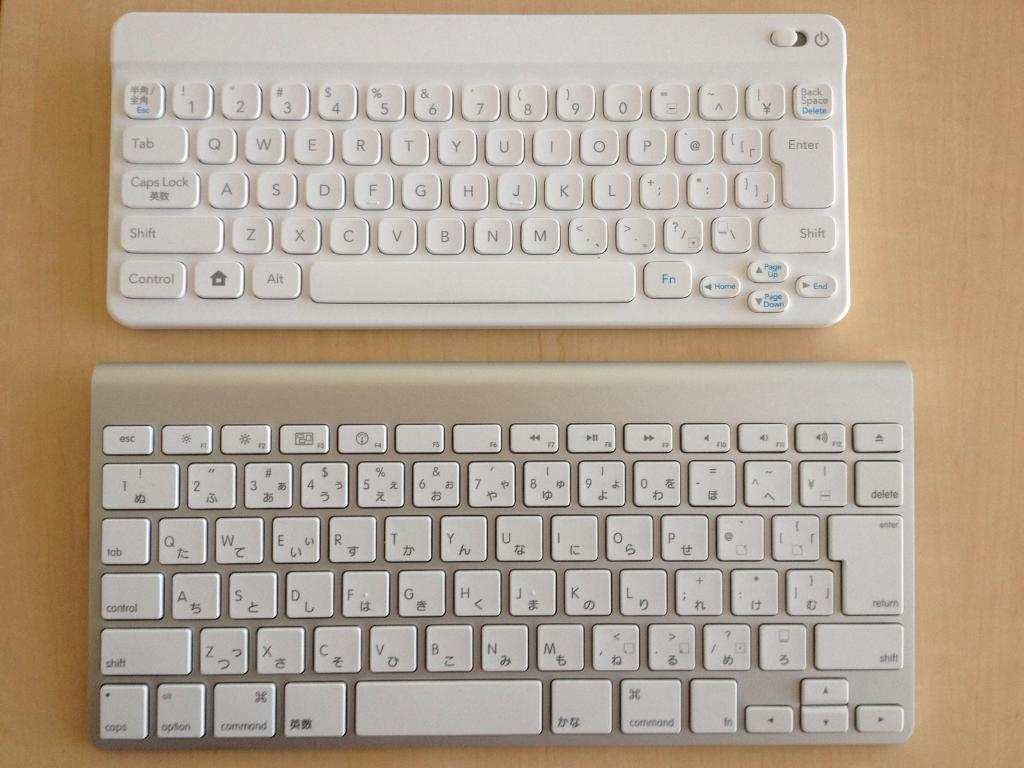What type of device is visible in the image? There are keyboards in the image. What is the color of the surface on which the keyboards are placed? The keyboards are on a brown color surface. Where is the crib located in the image? There is no crib present in the image. What type of explosive device is visible in the image? There is no explosive device present in the image. 